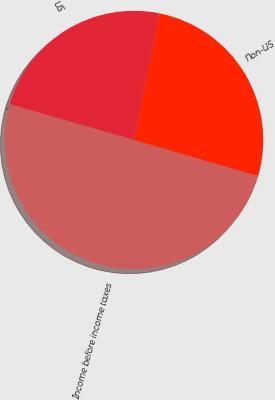Convert chart. <chart><loc_0><loc_0><loc_500><loc_500><pie_chart><fcel>US<fcel>Non-US<fcel>Income before income taxes<nl><fcel>23.7%<fcel>26.33%<fcel>49.97%<nl></chart> 